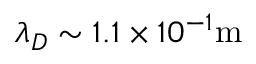Convert formula to latex. <formula><loc_0><loc_0><loc_500><loc_500>\lambda _ { D } \sim 1 . 1 \times 1 0 ^ { - 1 } m</formula> 